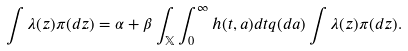Convert formula to latex. <formula><loc_0><loc_0><loc_500><loc_500>\int \lambda ( z ) \pi ( d z ) = \alpha + \beta \int _ { \mathbb { X } } \int _ { 0 } ^ { \infty } h ( t , a ) d t q ( d a ) \int \lambda ( z ) \pi ( d z ) .</formula> 